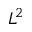<formula> <loc_0><loc_0><loc_500><loc_500>L ^ { 2 }</formula> 